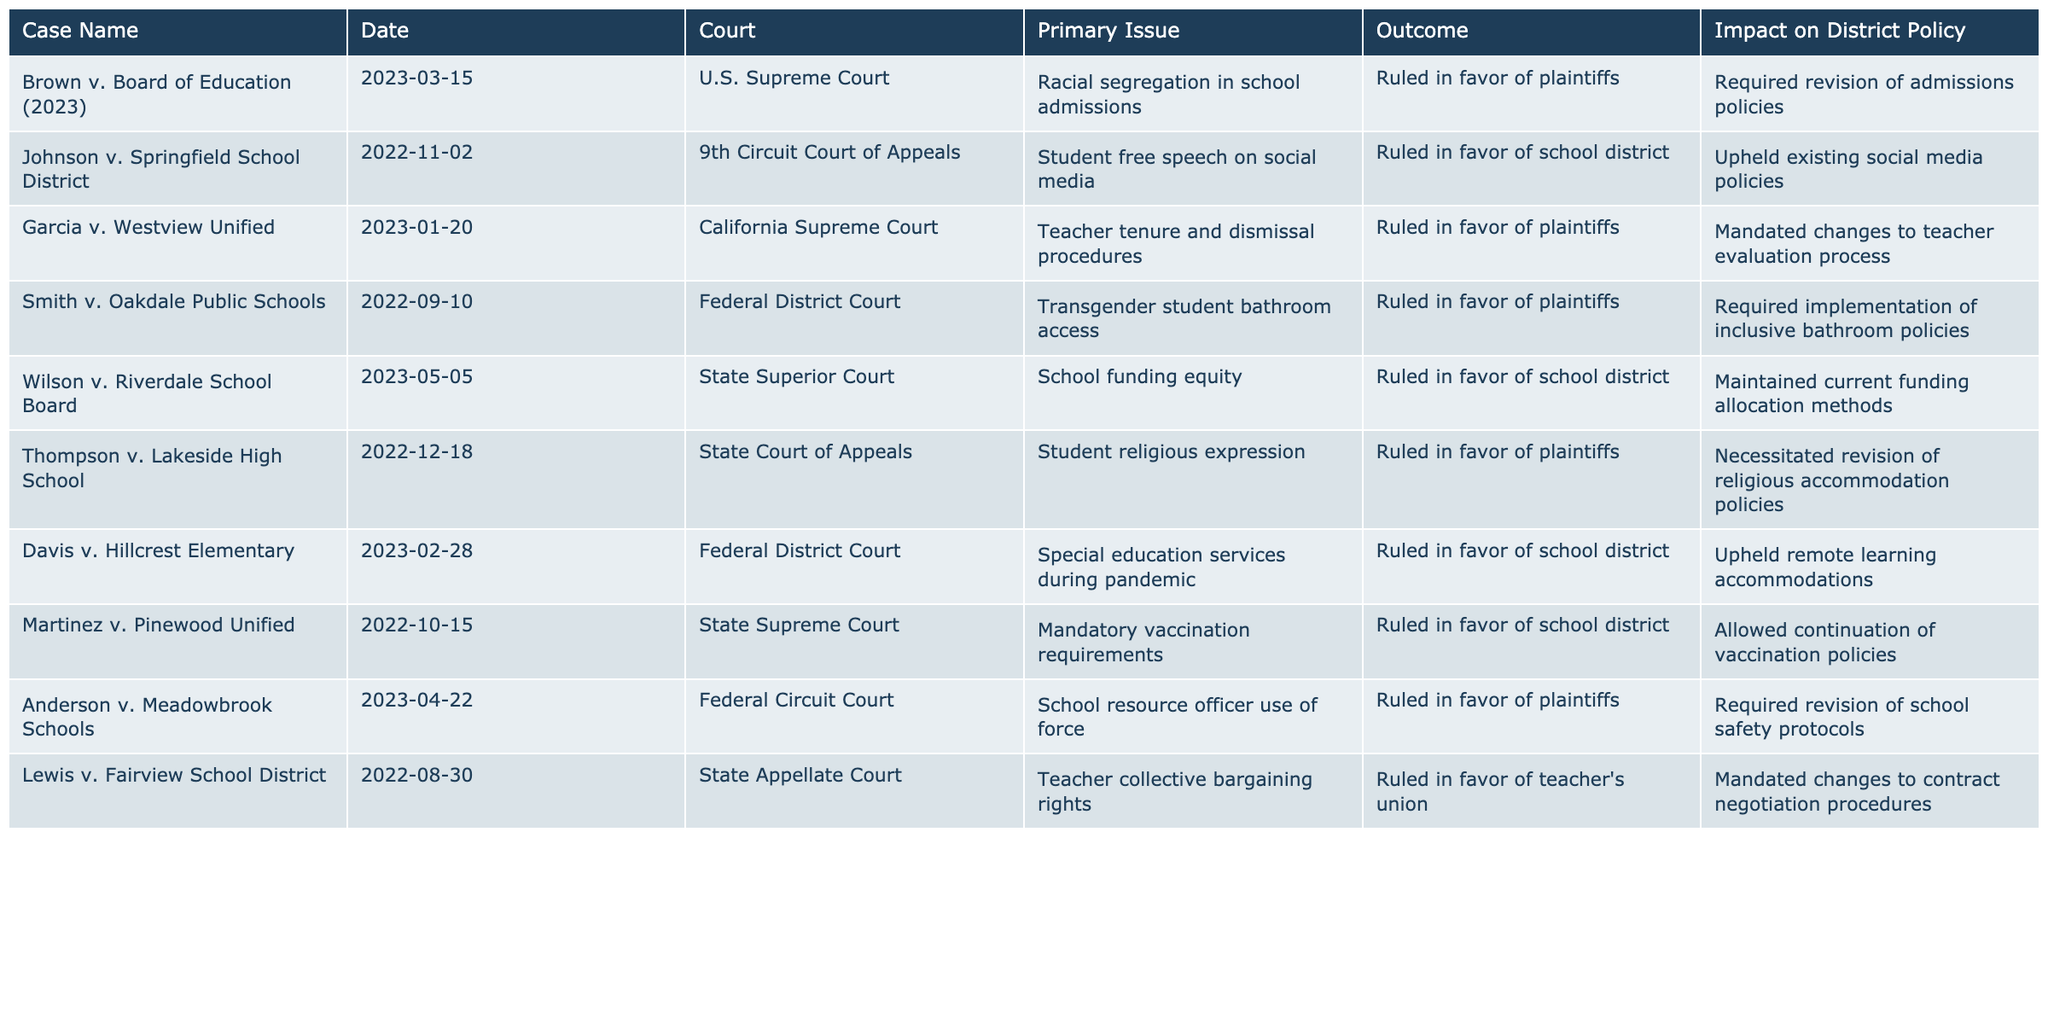What is the primary issue in Brown v. Board of Education (2023)? The primary issue is listed in the table under the column "Primary Issue" for that case, which states it is about racial segregation in school admissions.
Answer: Racial segregation in school admissions Which case resulted in the requirement for the revision of admissions policies? By examining the "Impact on District Policy" column, it can be seen that Brown v. Board of Education (2023) required a revision of admissions policies.
Answer: Brown v. Board of Education (2023) Did the Johnson v. Springfield School District case uphold existing social media policies? The table indicates that this case ruled in favor of the school district, which aligns with upholding their existing policies.
Answer: Yes What was the outcome of the Garcia v. Westview Unified case? The table shows that the case ruled in favor of the plaintiffs, which indicates that the plaintiffs won.
Answer: Ruled in favor of plaintiffs Which case required changes to the teacher evaluation process? The table indicates that Garcia v. Westview Unified resulted in mandated changes to the teacher evaluation process.
Answer: Garcia v. Westview Unified How many cases involved rulings in favor of the school district? By analyzing the table, we can identify the cases with outcomes in favor of the school district: Johnson v. Springfield, Davis v. Hillcrest, and Martinez v. Pinewood; totaling to three cases.
Answer: 3 Which court ruled on the Thompson v. Lakeside High School case? The "Court" column specifies that Thompson v. Lakeside High School was ruled in the State Court of Appeals.
Answer: State Court of Appeals How did the outcome of Lewis v. Fairview School District impact district policy? The impact stated in the table is that it mandated changes to contract negotiation procedures, which directly affects the district's policies regarding bargaining.
Answer: Mandated changes to contract negotiation procedures Is the outcome of Smith v. Oakdale Public Schools a positive or negative impact on district policy? Since the table shows that the outcome was in favor of the plaintiffs and required the implementation of inclusive bathroom policies, this can be viewed as a positive impact for inclusivity.
Answer: Positive impact What is the common trend in the outcomes of cases involving student rights? By evaluating the outcomes in the table, it can be noted that many cases involving student rights, such as Smith v. Oakdale and Thompson v. Lakeside, resulted in rulings favoring the plaintiffs, showing a trend of protecting student rights.
Answer: Favoring plaintiffs 